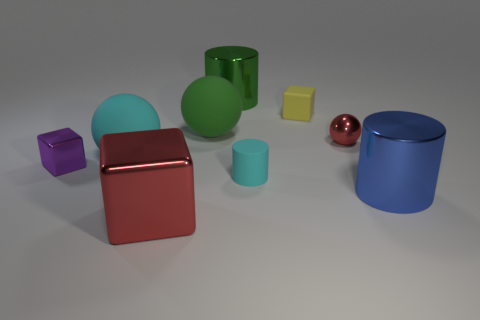Add 1 large cylinders. How many objects exist? 10 Subtract all cyan spheres. How many spheres are left? 2 Subtract all red spheres. How many spheres are left? 2 Subtract all cubes. How many objects are left? 6 Subtract 2 cylinders. How many cylinders are left? 1 Subtract all brown cubes. Subtract all gray cylinders. How many cubes are left? 3 Subtract all gray spheres. How many cyan cylinders are left? 1 Subtract all tiny gray matte objects. Subtract all red shiny objects. How many objects are left? 7 Add 4 metal cylinders. How many metal cylinders are left? 6 Add 7 green spheres. How many green spheres exist? 8 